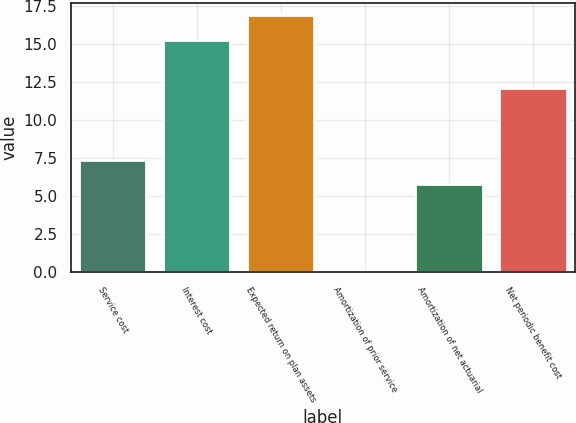Convert chart. <chart><loc_0><loc_0><loc_500><loc_500><bar_chart><fcel>Service cost<fcel>Interest cost<fcel>Expected return on plan assets<fcel>Amortization of prior service<fcel>Amortization of net actuarial<fcel>Net periodic benefit cost<nl><fcel>7.39<fcel>15.3<fcel>16.89<fcel>0.1<fcel>5.8<fcel>12.1<nl></chart> 